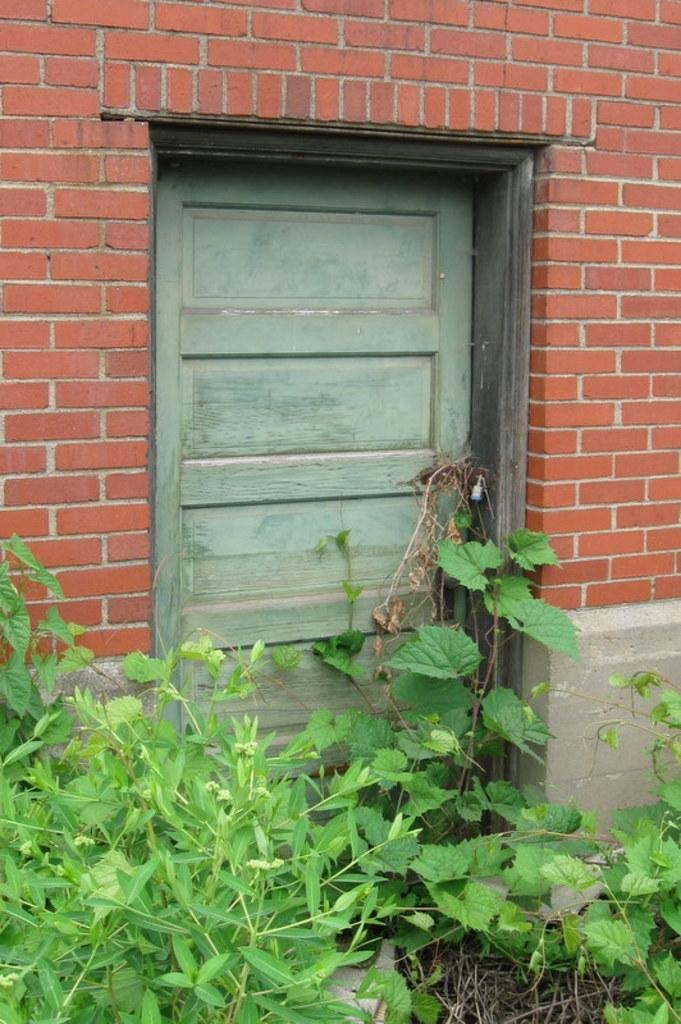What type of door is visible in the image? There is a wooden door in the image. What is the wooden door attached to? The wooden door is attached to a wall in the image. What other objects can be seen in the image? There are plants visible in the image. What type of badge is hanging on the wooden door in the image? There is no badge visible in the image; only the wooden door, wall, and plants are present. 